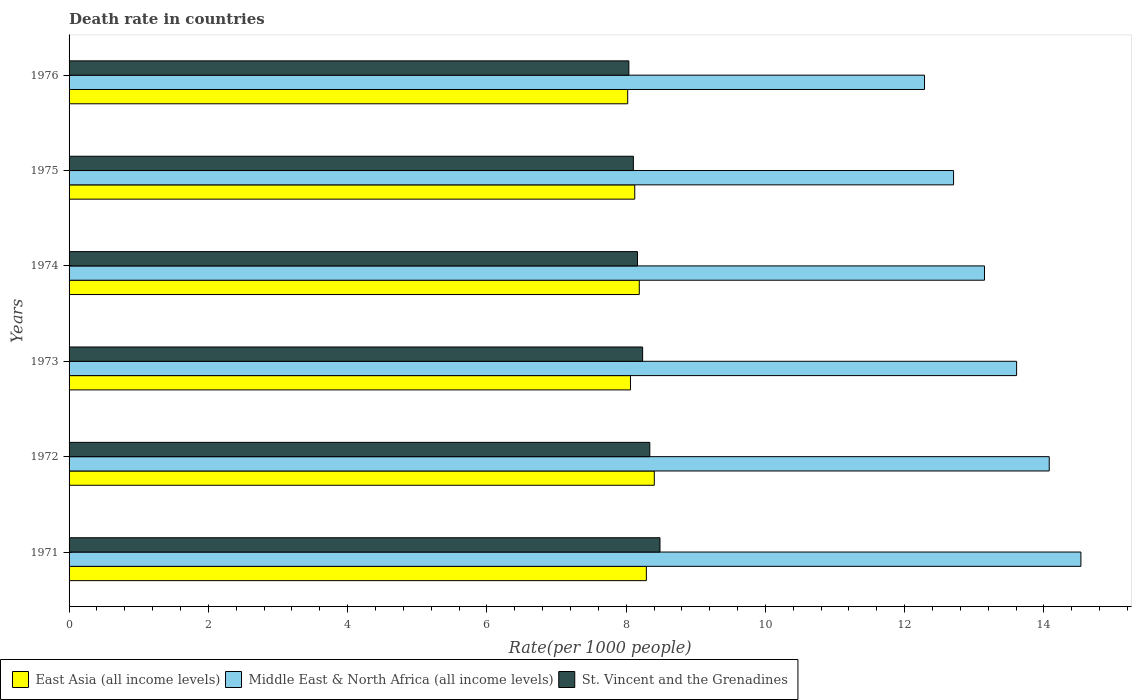How many groups of bars are there?
Your answer should be very brief. 6. How many bars are there on the 2nd tick from the bottom?
Provide a succinct answer. 3. What is the label of the 3rd group of bars from the top?
Provide a short and direct response. 1974. What is the death rate in Middle East & North Africa (all income levels) in 1973?
Your response must be concise. 13.61. Across all years, what is the maximum death rate in East Asia (all income levels)?
Your answer should be compact. 8.4. Across all years, what is the minimum death rate in Middle East & North Africa (all income levels)?
Offer a terse response. 12.29. In which year was the death rate in East Asia (all income levels) minimum?
Offer a terse response. 1976. What is the total death rate in East Asia (all income levels) in the graph?
Offer a very short reply. 49.09. What is the difference between the death rate in Middle East & North Africa (all income levels) in 1973 and that in 1974?
Offer a terse response. 0.46. What is the difference between the death rate in Middle East & North Africa (all income levels) in 1971 and the death rate in East Asia (all income levels) in 1973?
Offer a very short reply. 6.47. What is the average death rate in Middle East & North Africa (all income levels) per year?
Your answer should be very brief. 13.39. In the year 1973, what is the difference between the death rate in East Asia (all income levels) and death rate in Middle East & North Africa (all income levels)?
Keep it short and to the point. -5.55. What is the ratio of the death rate in St. Vincent and the Grenadines in 1973 to that in 1975?
Your answer should be compact. 1.02. What is the difference between the highest and the second highest death rate in East Asia (all income levels)?
Make the answer very short. 0.11. What is the difference between the highest and the lowest death rate in St. Vincent and the Grenadines?
Make the answer very short. 0.45. What does the 3rd bar from the top in 1974 represents?
Your answer should be very brief. East Asia (all income levels). What does the 1st bar from the bottom in 1974 represents?
Ensure brevity in your answer.  East Asia (all income levels). How many bars are there?
Offer a very short reply. 18. Are all the bars in the graph horizontal?
Your response must be concise. Yes. Does the graph contain any zero values?
Offer a terse response. No. Where does the legend appear in the graph?
Provide a short and direct response. Bottom left. What is the title of the graph?
Keep it short and to the point. Death rate in countries. Does "St. Kitts and Nevis" appear as one of the legend labels in the graph?
Provide a short and direct response. No. What is the label or title of the X-axis?
Your response must be concise. Rate(per 1000 people). What is the Rate(per 1000 people) in East Asia (all income levels) in 1971?
Give a very brief answer. 8.29. What is the Rate(per 1000 people) in Middle East & North Africa (all income levels) in 1971?
Your response must be concise. 14.53. What is the Rate(per 1000 people) in St. Vincent and the Grenadines in 1971?
Your answer should be very brief. 8.49. What is the Rate(per 1000 people) of East Asia (all income levels) in 1972?
Provide a short and direct response. 8.4. What is the Rate(per 1000 people) in Middle East & North Africa (all income levels) in 1972?
Provide a short and direct response. 14.08. What is the Rate(per 1000 people) in St. Vincent and the Grenadines in 1972?
Give a very brief answer. 8.34. What is the Rate(per 1000 people) in East Asia (all income levels) in 1973?
Offer a very short reply. 8.06. What is the Rate(per 1000 people) in Middle East & North Africa (all income levels) in 1973?
Your response must be concise. 13.61. What is the Rate(per 1000 people) of St. Vincent and the Grenadines in 1973?
Ensure brevity in your answer.  8.24. What is the Rate(per 1000 people) in East Asia (all income levels) in 1974?
Offer a very short reply. 8.19. What is the Rate(per 1000 people) of Middle East & North Africa (all income levels) in 1974?
Your answer should be compact. 13.15. What is the Rate(per 1000 people) in St. Vincent and the Grenadines in 1974?
Ensure brevity in your answer.  8.16. What is the Rate(per 1000 people) of East Asia (all income levels) in 1975?
Your response must be concise. 8.12. What is the Rate(per 1000 people) in Middle East & North Africa (all income levels) in 1975?
Provide a succinct answer. 12.7. What is the Rate(per 1000 people) in St. Vincent and the Grenadines in 1975?
Provide a succinct answer. 8.1. What is the Rate(per 1000 people) of East Asia (all income levels) in 1976?
Keep it short and to the point. 8.02. What is the Rate(per 1000 people) in Middle East & North Africa (all income levels) in 1976?
Keep it short and to the point. 12.29. What is the Rate(per 1000 people) in St. Vincent and the Grenadines in 1976?
Provide a short and direct response. 8.04. Across all years, what is the maximum Rate(per 1000 people) in East Asia (all income levels)?
Ensure brevity in your answer.  8.4. Across all years, what is the maximum Rate(per 1000 people) of Middle East & North Africa (all income levels)?
Provide a succinct answer. 14.53. Across all years, what is the maximum Rate(per 1000 people) of St. Vincent and the Grenadines?
Your answer should be very brief. 8.49. Across all years, what is the minimum Rate(per 1000 people) of East Asia (all income levels)?
Keep it short and to the point. 8.02. Across all years, what is the minimum Rate(per 1000 people) in Middle East & North Africa (all income levels)?
Offer a terse response. 12.29. Across all years, what is the minimum Rate(per 1000 people) of St. Vincent and the Grenadines?
Ensure brevity in your answer.  8.04. What is the total Rate(per 1000 people) in East Asia (all income levels) in the graph?
Your response must be concise. 49.09. What is the total Rate(per 1000 people) of Middle East & North Africa (all income levels) in the graph?
Ensure brevity in your answer.  80.35. What is the total Rate(per 1000 people) of St. Vincent and the Grenadines in the graph?
Ensure brevity in your answer.  49.37. What is the difference between the Rate(per 1000 people) of East Asia (all income levels) in 1971 and that in 1972?
Offer a very short reply. -0.11. What is the difference between the Rate(per 1000 people) of Middle East & North Africa (all income levels) in 1971 and that in 1972?
Your answer should be compact. 0.45. What is the difference between the Rate(per 1000 people) in St. Vincent and the Grenadines in 1971 and that in 1972?
Offer a very short reply. 0.15. What is the difference between the Rate(per 1000 people) of East Asia (all income levels) in 1971 and that in 1973?
Make the answer very short. 0.23. What is the difference between the Rate(per 1000 people) of Middle East & North Africa (all income levels) in 1971 and that in 1973?
Your answer should be very brief. 0.92. What is the difference between the Rate(per 1000 people) of St. Vincent and the Grenadines in 1971 and that in 1973?
Provide a succinct answer. 0.25. What is the difference between the Rate(per 1000 people) in East Asia (all income levels) in 1971 and that in 1974?
Make the answer very short. 0.1. What is the difference between the Rate(per 1000 people) of Middle East & North Africa (all income levels) in 1971 and that in 1974?
Keep it short and to the point. 1.38. What is the difference between the Rate(per 1000 people) of St. Vincent and the Grenadines in 1971 and that in 1974?
Make the answer very short. 0.32. What is the difference between the Rate(per 1000 people) of Middle East & North Africa (all income levels) in 1971 and that in 1975?
Provide a succinct answer. 1.83. What is the difference between the Rate(per 1000 people) in St. Vincent and the Grenadines in 1971 and that in 1975?
Offer a very short reply. 0.38. What is the difference between the Rate(per 1000 people) in East Asia (all income levels) in 1971 and that in 1976?
Your response must be concise. 0.27. What is the difference between the Rate(per 1000 people) of Middle East & North Africa (all income levels) in 1971 and that in 1976?
Offer a terse response. 2.25. What is the difference between the Rate(per 1000 people) in St. Vincent and the Grenadines in 1971 and that in 1976?
Offer a very short reply. 0.45. What is the difference between the Rate(per 1000 people) in East Asia (all income levels) in 1972 and that in 1973?
Make the answer very short. 0.34. What is the difference between the Rate(per 1000 people) of Middle East & North Africa (all income levels) in 1972 and that in 1973?
Your response must be concise. 0.47. What is the difference between the Rate(per 1000 people) of St. Vincent and the Grenadines in 1972 and that in 1973?
Keep it short and to the point. 0.1. What is the difference between the Rate(per 1000 people) of East Asia (all income levels) in 1972 and that in 1974?
Offer a terse response. 0.22. What is the difference between the Rate(per 1000 people) in Middle East & North Africa (all income levels) in 1972 and that in 1974?
Make the answer very short. 0.93. What is the difference between the Rate(per 1000 people) of St. Vincent and the Grenadines in 1972 and that in 1974?
Provide a succinct answer. 0.18. What is the difference between the Rate(per 1000 people) of East Asia (all income levels) in 1972 and that in 1975?
Ensure brevity in your answer.  0.28. What is the difference between the Rate(per 1000 people) in Middle East & North Africa (all income levels) in 1972 and that in 1975?
Provide a succinct answer. 1.37. What is the difference between the Rate(per 1000 people) in St. Vincent and the Grenadines in 1972 and that in 1975?
Keep it short and to the point. 0.24. What is the difference between the Rate(per 1000 people) in East Asia (all income levels) in 1972 and that in 1976?
Ensure brevity in your answer.  0.38. What is the difference between the Rate(per 1000 people) of Middle East & North Africa (all income levels) in 1972 and that in 1976?
Your answer should be very brief. 1.79. What is the difference between the Rate(per 1000 people) of St. Vincent and the Grenadines in 1972 and that in 1976?
Your response must be concise. 0.3. What is the difference between the Rate(per 1000 people) in East Asia (all income levels) in 1973 and that in 1974?
Ensure brevity in your answer.  -0.13. What is the difference between the Rate(per 1000 people) of Middle East & North Africa (all income levels) in 1973 and that in 1974?
Provide a short and direct response. 0.46. What is the difference between the Rate(per 1000 people) in St. Vincent and the Grenadines in 1973 and that in 1974?
Your response must be concise. 0.07. What is the difference between the Rate(per 1000 people) in East Asia (all income levels) in 1973 and that in 1975?
Provide a succinct answer. -0.06. What is the difference between the Rate(per 1000 people) in Middle East & North Africa (all income levels) in 1973 and that in 1975?
Your answer should be very brief. 0.91. What is the difference between the Rate(per 1000 people) of St. Vincent and the Grenadines in 1973 and that in 1975?
Ensure brevity in your answer.  0.13. What is the difference between the Rate(per 1000 people) in East Asia (all income levels) in 1973 and that in 1976?
Offer a very short reply. 0.04. What is the difference between the Rate(per 1000 people) of Middle East & North Africa (all income levels) in 1973 and that in 1976?
Offer a very short reply. 1.32. What is the difference between the Rate(per 1000 people) of St. Vincent and the Grenadines in 1973 and that in 1976?
Keep it short and to the point. 0.2. What is the difference between the Rate(per 1000 people) of East Asia (all income levels) in 1974 and that in 1975?
Provide a short and direct response. 0.06. What is the difference between the Rate(per 1000 people) in Middle East & North Africa (all income levels) in 1974 and that in 1975?
Give a very brief answer. 0.44. What is the difference between the Rate(per 1000 people) in St. Vincent and the Grenadines in 1974 and that in 1975?
Your answer should be very brief. 0.06. What is the difference between the Rate(per 1000 people) in East Asia (all income levels) in 1974 and that in 1976?
Make the answer very short. 0.17. What is the difference between the Rate(per 1000 people) in Middle East & North Africa (all income levels) in 1974 and that in 1976?
Provide a succinct answer. 0.86. What is the difference between the Rate(per 1000 people) in St. Vincent and the Grenadines in 1974 and that in 1976?
Make the answer very short. 0.12. What is the difference between the Rate(per 1000 people) of East Asia (all income levels) in 1975 and that in 1976?
Your response must be concise. 0.1. What is the difference between the Rate(per 1000 people) in Middle East & North Africa (all income levels) in 1975 and that in 1976?
Your response must be concise. 0.42. What is the difference between the Rate(per 1000 people) in St. Vincent and the Grenadines in 1975 and that in 1976?
Offer a terse response. 0.07. What is the difference between the Rate(per 1000 people) of East Asia (all income levels) in 1971 and the Rate(per 1000 people) of Middle East & North Africa (all income levels) in 1972?
Keep it short and to the point. -5.79. What is the difference between the Rate(per 1000 people) of East Asia (all income levels) in 1971 and the Rate(per 1000 people) of St. Vincent and the Grenadines in 1972?
Provide a succinct answer. -0.05. What is the difference between the Rate(per 1000 people) of Middle East & North Africa (all income levels) in 1971 and the Rate(per 1000 people) of St. Vincent and the Grenadines in 1972?
Offer a terse response. 6.19. What is the difference between the Rate(per 1000 people) of East Asia (all income levels) in 1971 and the Rate(per 1000 people) of Middle East & North Africa (all income levels) in 1973?
Provide a succinct answer. -5.32. What is the difference between the Rate(per 1000 people) in East Asia (all income levels) in 1971 and the Rate(per 1000 people) in St. Vincent and the Grenadines in 1973?
Your answer should be compact. 0.05. What is the difference between the Rate(per 1000 people) in Middle East & North Africa (all income levels) in 1971 and the Rate(per 1000 people) in St. Vincent and the Grenadines in 1973?
Provide a succinct answer. 6.29. What is the difference between the Rate(per 1000 people) in East Asia (all income levels) in 1971 and the Rate(per 1000 people) in Middle East & North Africa (all income levels) in 1974?
Provide a succinct answer. -4.86. What is the difference between the Rate(per 1000 people) in East Asia (all income levels) in 1971 and the Rate(per 1000 people) in St. Vincent and the Grenadines in 1974?
Ensure brevity in your answer.  0.13. What is the difference between the Rate(per 1000 people) of Middle East & North Africa (all income levels) in 1971 and the Rate(per 1000 people) of St. Vincent and the Grenadines in 1974?
Provide a succinct answer. 6.37. What is the difference between the Rate(per 1000 people) of East Asia (all income levels) in 1971 and the Rate(per 1000 people) of Middle East & North Africa (all income levels) in 1975?
Provide a succinct answer. -4.41. What is the difference between the Rate(per 1000 people) of East Asia (all income levels) in 1971 and the Rate(per 1000 people) of St. Vincent and the Grenadines in 1975?
Provide a short and direct response. 0.19. What is the difference between the Rate(per 1000 people) of Middle East & North Africa (all income levels) in 1971 and the Rate(per 1000 people) of St. Vincent and the Grenadines in 1975?
Keep it short and to the point. 6.43. What is the difference between the Rate(per 1000 people) in East Asia (all income levels) in 1971 and the Rate(per 1000 people) in Middle East & North Africa (all income levels) in 1976?
Ensure brevity in your answer.  -3.99. What is the difference between the Rate(per 1000 people) in East Asia (all income levels) in 1971 and the Rate(per 1000 people) in St. Vincent and the Grenadines in 1976?
Your answer should be very brief. 0.25. What is the difference between the Rate(per 1000 people) in Middle East & North Africa (all income levels) in 1971 and the Rate(per 1000 people) in St. Vincent and the Grenadines in 1976?
Ensure brevity in your answer.  6.49. What is the difference between the Rate(per 1000 people) in East Asia (all income levels) in 1972 and the Rate(per 1000 people) in Middle East & North Africa (all income levels) in 1973?
Offer a terse response. -5.2. What is the difference between the Rate(per 1000 people) of East Asia (all income levels) in 1972 and the Rate(per 1000 people) of St. Vincent and the Grenadines in 1973?
Offer a very short reply. 0.17. What is the difference between the Rate(per 1000 people) of Middle East & North Africa (all income levels) in 1972 and the Rate(per 1000 people) of St. Vincent and the Grenadines in 1973?
Offer a terse response. 5.84. What is the difference between the Rate(per 1000 people) in East Asia (all income levels) in 1972 and the Rate(per 1000 people) in Middle East & North Africa (all income levels) in 1974?
Make the answer very short. -4.74. What is the difference between the Rate(per 1000 people) of East Asia (all income levels) in 1972 and the Rate(per 1000 people) of St. Vincent and the Grenadines in 1974?
Keep it short and to the point. 0.24. What is the difference between the Rate(per 1000 people) of Middle East & North Africa (all income levels) in 1972 and the Rate(per 1000 people) of St. Vincent and the Grenadines in 1974?
Give a very brief answer. 5.91. What is the difference between the Rate(per 1000 people) in East Asia (all income levels) in 1972 and the Rate(per 1000 people) in Middle East & North Africa (all income levels) in 1975?
Give a very brief answer. -4.3. What is the difference between the Rate(per 1000 people) in East Asia (all income levels) in 1972 and the Rate(per 1000 people) in St. Vincent and the Grenadines in 1975?
Keep it short and to the point. 0.3. What is the difference between the Rate(per 1000 people) in Middle East & North Africa (all income levels) in 1972 and the Rate(per 1000 people) in St. Vincent and the Grenadines in 1975?
Your answer should be very brief. 5.97. What is the difference between the Rate(per 1000 people) of East Asia (all income levels) in 1972 and the Rate(per 1000 people) of Middle East & North Africa (all income levels) in 1976?
Provide a succinct answer. -3.88. What is the difference between the Rate(per 1000 people) of East Asia (all income levels) in 1972 and the Rate(per 1000 people) of St. Vincent and the Grenadines in 1976?
Give a very brief answer. 0.37. What is the difference between the Rate(per 1000 people) in Middle East & North Africa (all income levels) in 1972 and the Rate(per 1000 people) in St. Vincent and the Grenadines in 1976?
Offer a terse response. 6.04. What is the difference between the Rate(per 1000 people) of East Asia (all income levels) in 1973 and the Rate(per 1000 people) of Middle East & North Africa (all income levels) in 1974?
Keep it short and to the point. -5.08. What is the difference between the Rate(per 1000 people) in East Asia (all income levels) in 1973 and the Rate(per 1000 people) in St. Vincent and the Grenadines in 1974?
Your response must be concise. -0.1. What is the difference between the Rate(per 1000 people) of Middle East & North Africa (all income levels) in 1973 and the Rate(per 1000 people) of St. Vincent and the Grenadines in 1974?
Offer a terse response. 5.44. What is the difference between the Rate(per 1000 people) in East Asia (all income levels) in 1973 and the Rate(per 1000 people) in Middle East & North Africa (all income levels) in 1975?
Give a very brief answer. -4.64. What is the difference between the Rate(per 1000 people) of East Asia (all income levels) in 1973 and the Rate(per 1000 people) of St. Vincent and the Grenadines in 1975?
Offer a terse response. -0.04. What is the difference between the Rate(per 1000 people) in Middle East & North Africa (all income levels) in 1973 and the Rate(per 1000 people) in St. Vincent and the Grenadines in 1975?
Offer a terse response. 5.5. What is the difference between the Rate(per 1000 people) in East Asia (all income levels) in 1973 and the Rate(per 1000 people) in Middle East & North Africa (all income levels) in 1976?
Your answer should be compact. -4.22. What is the difference between the Rate(per 1000 people) in East Asia (all income levels) in 1973 and the Rate(per 1000 people) in St. Vincent and the Grenadines in 1976?
Offer a terse response. 0.02. What is the difference between the Rate(per 1000 people) in Middle East & North Africa (all income levels) in 1973 and the Rate(per 1000 people) in St. Vincent and the Grenadines in 1976?
Give a very brief answer. 5.57. What is the difference between the Rate(per 1000 people) of East Asia (all income levels) in 1974 and the Rate(per 1000 people) of Middle East & North Africa (all income levels) in 1975?
Give a very brief answer. -4.51. What is the difference between the Rate(per 1000 people) of East Asia (all income levels) in 1974 and the Rate(per 1000 people) of St. Vincent and the Grenadines in 1975?
Provide a short and direct response. 0.08. What is the difference between the Rate(per 1000 people) of Middle East & North Africa (all income levels) in 1974 and the Rate(per 1000 people) of St. Vincent and the Grenadines in 1975?
Keep it short and to the point. 5.04. What is the difference between the Rate(per 1000 people) in East Asia (all income levels) in 1974 and the Rate(per 1000 people) in Middle East & North Africa (all income levels) in 1976?
Ensure brevity in your answer.  -4.1. What is the difference between the Rate(per 1000 people) of East Asia (all income levels) in 1974 and the Rate(per 1000 people) of St. Vincent and the Grenadines in 1976?
Your answer should be very brief. 0.15. What is the difference between the Rate(per 1000 people) of Middle East & North Africa (all income levels) in 1974 and the Rate(per 1000 people) of St. Vincent and the Grenadines in 1976?
Your response must be concise. 5.11. What is the difference between the Rate(per 1000 people) in East Asia (all income levels) in 1975 and the Rate(per 1000 people) in Middle East & North Africa (all income levels) in 1976?
Keep it short and to the point. -4.16. What is the difference between the Rate(per 1000 people) in East Asia (all income levels) in 1975 and the Rate(per 1000 people) in St. Vincent and the Grenadines in 1976?
Offer a very short reply. 0.08. What is the difference between the Rate(per 1000 people) of Middle East & North Africa (all income levels) in 1975 and the Rate(per 1000 people) of St. Vincent and the Grenadines in 1976?
Give a very brief answer. 4.66. What is the average Rate(per 1000 people) of East Asia (all income levels) per year?
Ensure brevity in your answer.  8.18. What is the average Rate(per 1000 people) of Middle East & North Africa (all income levels) per year?
Your answer should be compact. 13.39. What is the average Rate(per 1000 people) of St. Vincent and the Grenadines per year?
Give a very brief answer. 8.23. In the year 1971, what is the difference between the Rate(per 1000 people) in East Asia (all income levels) and Rate(per 1000 people) in Middle East & North Africa (all income levels)?
Your response must be concise. -6.24. In the year 1971, what is the difference between the Rate(per 1000 people) in East Asia (all income levels) and Rate(per 1000 people) in St. Vincent and the Grenadines?
Offer a terse response. -0.2. In the year 1971, what is the difference between the Rate(per 1000 people) in Middle East & North Africa (all income levels) and Rate(per 1000 people) in St. Vincent and the Grenadines?
Provide a short and direct response. 6.04. In the year 1972, what is the difference between the Rate(per 1000 people) in East Asia (all income levels) and Rate(per 1000 people) in Middle East & North Africa (all income levels)?
Your answer should be compact. -5.67. In the year 1972, what is the difference between the Rate(per 1000 people) of East Asia (all income levels) and Rate(per 1000 people) of St. Vincent and the Grenadines?
Make the answer very short. 0.06. In the year 1972, what is the difference between the Rate(per 1000 people) in Middle East & North Africa (all income levels) and Rate(per 1000 people) in St. Vincent and the Grenadines?
Your answer should be compact. 5.74. In the year 1973, what is the difference between the Rate(per 1000 people) in East Asia (all income levels) and Rate(per 1000 people) in Middle East & North Africa (all income levels)?
Offer a terse response. -5.54. In the year 1973, what is the difference between the Rate(per 1000 people) in East Asia (all income levels) and Rate(per 1000 people) in St. Vincent and the Grenadines?
Offer a terse response. -0.17. In the year 1973, what is the difference between the Rate(per 1000 people) in Middle East & North Africa (all income levels) and Rate(per 1000 people) in St. Vincent and the Grenadines?
Provide a succinct answer. 5.37. In the year 1974, what is the difference between the Rate(per 1000 people) of East Asia (all income levels) and Rate(per 1000 people) of Middle East & North Africa (all income levels)?
Offer a terse response. -4.96. In the year 1974, what is the difference between the Rate(per 1000 people) of East Asia (all income levels) and Rate(per 1000 people) of St. Vincent and the Grenadines?
Your answer should be very brief. 0.03. In the year 1974, what is the difference between the Rate(per 1000 people) of Middle East & North Africa (all income levels) and Rate(per 1000 people) of St. Vincent and the Grenadines?
Your response must be concise. 4.98. In the year 1975, what is the difference between the Rate(per 1000 people) of East Asia (all income levels) and Rate(per 1000 people) of Middle East & North Africa (all income levels)?
Offer a terse response. -4.58. In the year 1975, what is the difference between the Rate(per 1000 people) of East Asia (all income levels) and Rate(per 1000 people) of St. Vincent and the Grenadines?
Keep it short and to the point. 0.02. In the year 1975, what is the difference between the Rate(per 1000 people) in Middle East & North Africa (all income levels) and Rate(per 1000 people) in St. Vincent and the Grenadines?
Offer a terse response. 4.6. In the year 1976, what is the difference between the Rate(per 1000 people) in East Asia (all income levels) and Rate(per 1000 people) in Middle East & North Africa (all income levels)?
Ensure brevity in your answer.  -4.26. In the year 1976, what is the difference between the Rate(per 1000 people) of East Asia (all income levels) and Rate(per 1000 people) of St. Vincent and the Grenadines?
Your response must be concise. -0.02. In the year 1976, what is the difference between the Rate(per 1000 people) of Middle East & North Africa (all income levels) and Rate(per 1000 people) of St. Vincent and the Grenadines?
Provide a succinct answer. 4.25. What is the ratio of the Rate(per 1000 people) in East Asia (all income levels) in 1971 to that in 1972?
Make the answer very short. 0.99. What is the ratio of the Rate(per 1000 people) in Middle East & North Africa (all income levels) in 1971 to that in 1972?
Provide a succinct answer. 1.03. What is the ratio of the Rate(per 1000 people) of St. Vincent and the Grenadines in 1971 to that in 1972?
Offer a terse response. 1.02. What is the ratio of the Rate(per 1000 people) of East Asia (all income levels) in 1971 to that in 1973?
Ensure brevity in your answer.  1.03. What is the ratio of the Rate(per 1000 people) of Middle East & North Africa (all income levels) in 1971 to that in 1973?
Offer a very short reply. 1.07. What is the ratio of the Rate(per 1000 people) of St. Vincent and the Grenadines in 1971 to that in 1973?
Keep it short and to the point. 1.03. What is the ratio of the Rate(per 1000 people) of East Asia (all income levels) in 1971 to that in 1974?
Provide a short and direct response. 1.01. What is the ratio of the Rate(per 1000 people) in Middle East & North Africa (all income levels) in 1971 to that in 1974?
Your answer should be very brief. 1.11. What is the ratio of the Rate(per 1000 people) of St. Vincent and the Grenadines in 1971 to that in 1974?
Offer a very short reply. 1.04. What is the ratio of the Rate(per 1000 people) of East Asia (all income levels) in 1971 to that in 1975?
Offer a very short reply. 1.02. What is the ratio of the Rate(per 1000 people) in Middle East & North Africa (all income levels) in 1971 to that in 1975?
Ensure brevity in your answer.  1.14. What is the ratio of the Rate(per 1000 people) of St. Vincent and the Grenadines in 1971 to that in 1975?
Ensure brevity in your answer.  1.05. What is the ratio of the Rate(per 1000 people) in East Asia (all income levels) in 1971 to that in 1976?
Make the answer very short. 1.03. What is the ratio of the Rate(per 1000 people) of Middle East & North Africa (all income levels) in 1971 to that in 1976?
Your answer should be compact. 1.18. What is the ratio of the Rate(per 1000 people) in St. Vincent and the Grenadines in 1971 to that in 1976?
Provide a succinct answer. 1.06. What is the ratio of the Rate(per 1000 people) in East Asia (all income levels) in 1972 to that in 1973?
Your answer should be very brief. 1.04. What is the ratio of the Rate(per 1000 people) of Middle East & North Africa (all income levels) in 1972 to that in 1973?
Provide a short and direct response. 1.03. What is the ratio of the Rate(per 1000 people) of St. Vincent and the Grenadines in 1972 to that in 1973?
Provide a succinct answer. 1.01. What is the ratio of the Rate(per 1000 people) of East Asia (all income levels) in 1972 to that in 1974?
Your response must be concise. 1.03. What is the ratio of the Rate(per 1000 people) of Middle East & North Africa (all income levels) in 1972 to that in 1974?
Provide a succinct answer. 1.07. What is the ratio of the Rate(per 1000 people) of St. Vincent and the Grenadines in 1972 to that in 1974?
Keep it short and to the point. 1.02. What is the ratio of the Rate(per 1000 people) in East Asia (all income levels) in 1972 to that in 1975?
Your answer should be very brief. 1.03. What is the ratio of the Rate(per 1000 people) in Middle East & North Africa (all income levels) in 1972 to that in 1975?
Your response must be concise. 1.11. What is the ratio of the Rate(per 1000 people) of St. Vincent and the Grenadines in 1972 to that in 1975?
Your answer should be very brief. 1.03. What is the ratio of the Rate(per 1000 people) in East Asia (all income levels) in 1972 to that in 1976?
Ensure brevity in your answer.  1.05. What is the ratio of the Rate(per 1000 people) in Middle East & North Africa (all income levels) in 1972 to that in 1976?
Your answer should be compact. 1.15. What is the ratio of the Rate(per 1000 people) in St. Vincent and the Grenadines in 1972 to that in 1976?
Provide a short and direct response. 1.04. What is the ratio of the Rate(per 1000 people) of East Asia (all income levels) in 1973 to that in 1974?
Provide a short and direct response. 0.98. What is the ratio of the Rate(per 1000 people) of Middle East & North Africa (all income levels) in 1973 to that in 1974?
Your answer should be very brief. 1.04. What is the ratio of the Rate(per 1000 people) of St. Vincent and the Grenadines in 1973 to that in 1974?
Offer a terse response. 1.01. What is the ratio of the Rate(per 1000 people) of East Asia (all income levels) in 1973 to that in 1975?
Offer a terse response. 0.99. What is the ratio of the Rate(per 1000 people) of Middle East & North Africa (all income levels) in 1973 to that in 1975?
Ensure brevity in your answer.  1.07. What is the ratio of the Rate(per 1000 people) of St. Vincent and the Grenadines in 1973 to that in 1975?
Your answer should be compact. 1.02. What is the ratio of the Rate(per 1000 people) in Middle East & North Africa (all income levels) in 1973 to that in 1976?
Your answer should be compact. 1.11. What is the ratio of the Rate(per 1000 people) in St. Vincent and the Grenadines in 1973 to that in 1976?
Your answer should be compact. 1.02. What is the ratio of the Rate(per 1000 people) in Middle East & North Africa (all income levels) in 1974 to that in 1975?
Give a very brief answer. 1.03. What is the ratio of the Rate(per 1000 people) in St. Vincent and the Grenadines in 1974 to that in 1975?
Keep it short and to the point. 1.01. What is the ratio of the Rate(per 1000 people) in East Asia (all income levels) in 1974 to that in 1976?
Provide a succinct answer. 1.02. What is the ratio of the Rate(per 1000 people) in Middle East & North Africa (all income levels) in 1974 to that in 1976?
Provide a succinct answer. 1.07. What is the ratio of the Rate(per 1000 people) of St. Vincent and the Grenadines in 1974 to that in 1976?
Make the answer very short. 1.02. What is the ratio of the Rate(per 1000 people) in East Asia (all income levels) in 1975 to that in 1976?
Your response must be concise. 1.01. What is the ratio of the Rate(per 1000 people) in Middle East & North Africa (all income levels) in 1975 to that in 1976?
Ensure brevity in your answer.  1.03. What is the difference between the highest and the second highest Rate(per 1000 people) of East Asia (all income levels)?
Provide a succinct answer. 0.11. What is the difference between the highest and the second highest Rate(per 1000 people) in Middle East & North Africa (all income levels)?
Your answer should be compact. 0.45. What is the difference between the highest and the second highest Rate(per 1000 people) in St. Vincent and the Grenadines?
Provide a succinct answer. 0.15. What is the difference between the highest and the lowest Rate(per 1000 people) in East Asia (all income levels)?
Your response must be concise. 0.38. What is the difference between the highest and the lowest Rate(per 1000 people) in Middle East & North Africa (all income levels)?
Provide a succinct answer. 2.25. What is the difference between the highest and the lowest Rate(per 1000 people) of St. Vincent and the Grenadines?
Provide a succinct answer. 0.45. 